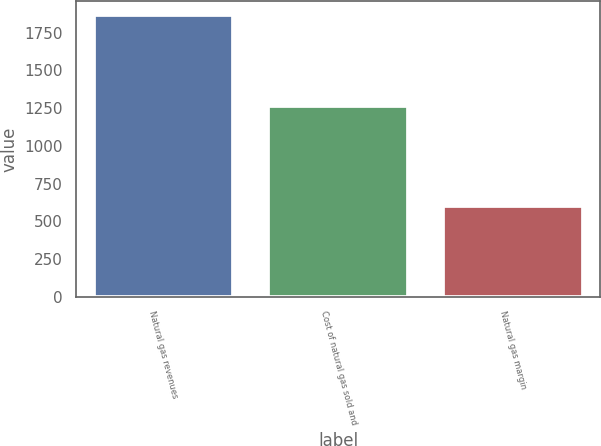<chart> <loc_0><loc_0><loc_500><loc_500><bar_chart><fcel>Natural gas revenues<fcel>Cost of natural gas sold and<fcel>Natural gas margin<nl><fcel>1866<fcel>1266<fcel>600<nl></chart> 